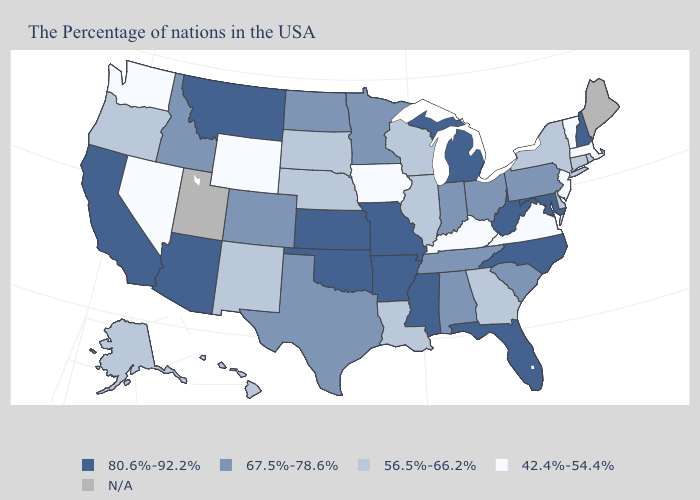What is the value of Wyoming?
Concise answer only. 42.4%-54.4%. What is the value of Tennessee?
Quick response, please. 67.5%-78.6%. What is the lowest value in the USA?
Short answer required. 42.4%-54.4%. Which states have the lowest value in the West?
Quick response, please. Wyoming, Nevada, Washington. What is the value of Texas?
Concise answer only. 67.5%-78.6%. Name the states that have a value in the range 42.4%-54.4%?
Be succinct. Massachusetts, Vermont, New Jersey, Virginia, Kentucky, Iowa, Wyoming, Nevada, Washington. What is the highest value in the USA?
Concise answer only. 80.6%-92.2%. Name the states that have a value in the range 67.5%-78.6%?
Write a very short answer. Pennsylvania, South Carolina, Ohio, Indiana, Alabama, Tennessee, Minnesota, Texas, North Dakota, Colorado, Idaho. Among the states that border Rhode Island , which have the highest value?
Keep it brief. Connecticut. Name the states that have a value in the range N/A?
Concise answer only. Maine, Utah. Name the states that have a value in the range N/A?
Quick response, please. Maine, Utah. What is the value of Wisconsin?
Write a very short answer. 56.5%-66.2%. 